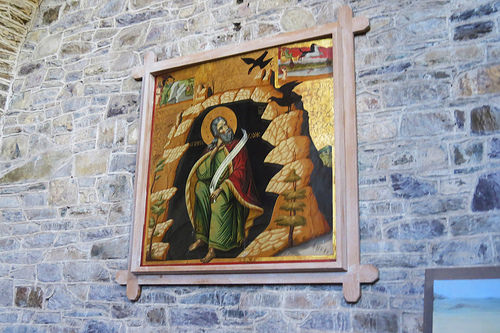<image>
Is there a tree under the pond? Yes. The tree is positioned underneath the pond, with the pond above it in the vertical space. 